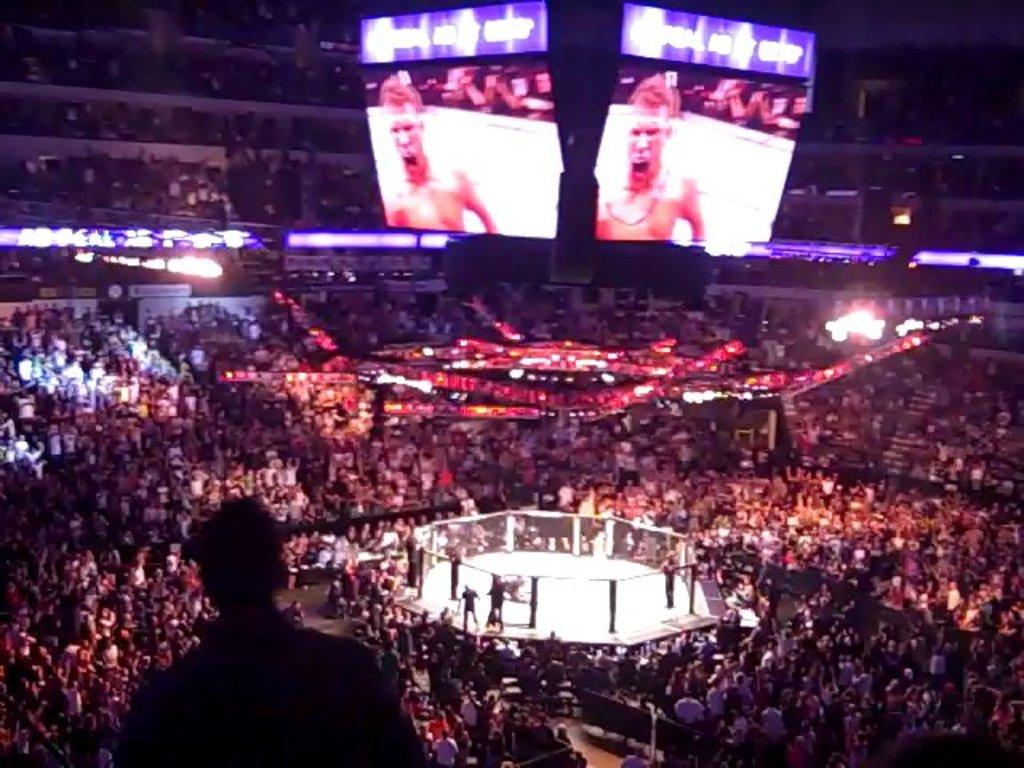What are the people in the image doing? The groups of people in the image are standing and sitting. What type of setting is depicted in the image? The scene appears to be a boxing ring. What objects are hanging from the roof in the image? There are two screens hanging from the roof. What can be seen in the image that provides illumination? There are lights visible in the image. What type of wax is being used to create the animal sculptures in the image? There are no animal sculptures present in the image, so wax is not being used for that purpose. 